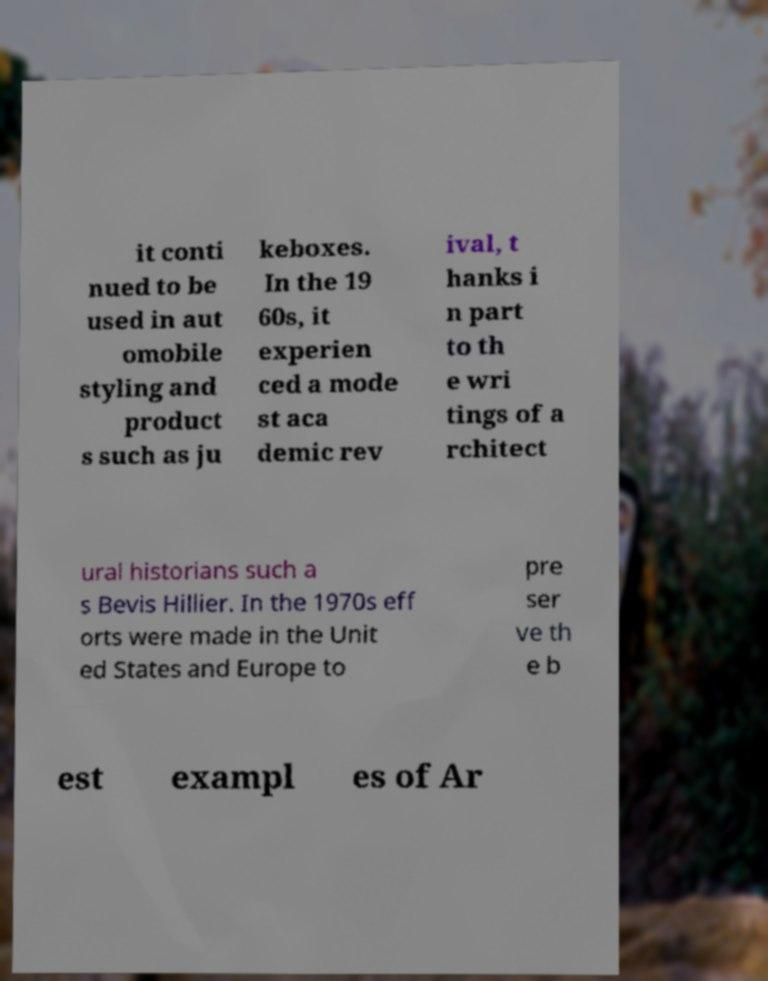Could you assist in decoding the text presented in this image and type it out clearly? it conti nued to be used in aut omobile styling and product s such as ju keboxes. In the 19 60s, it experien ced a mode st aca demic rev ival, t hanks i n part to th e wri tings of a rchitect ural historians such a s Bevis Hillier. In the 1970s eff orts were made in the Unit ed States and Europe to pre ser ve th e b est exampl es of Ar 